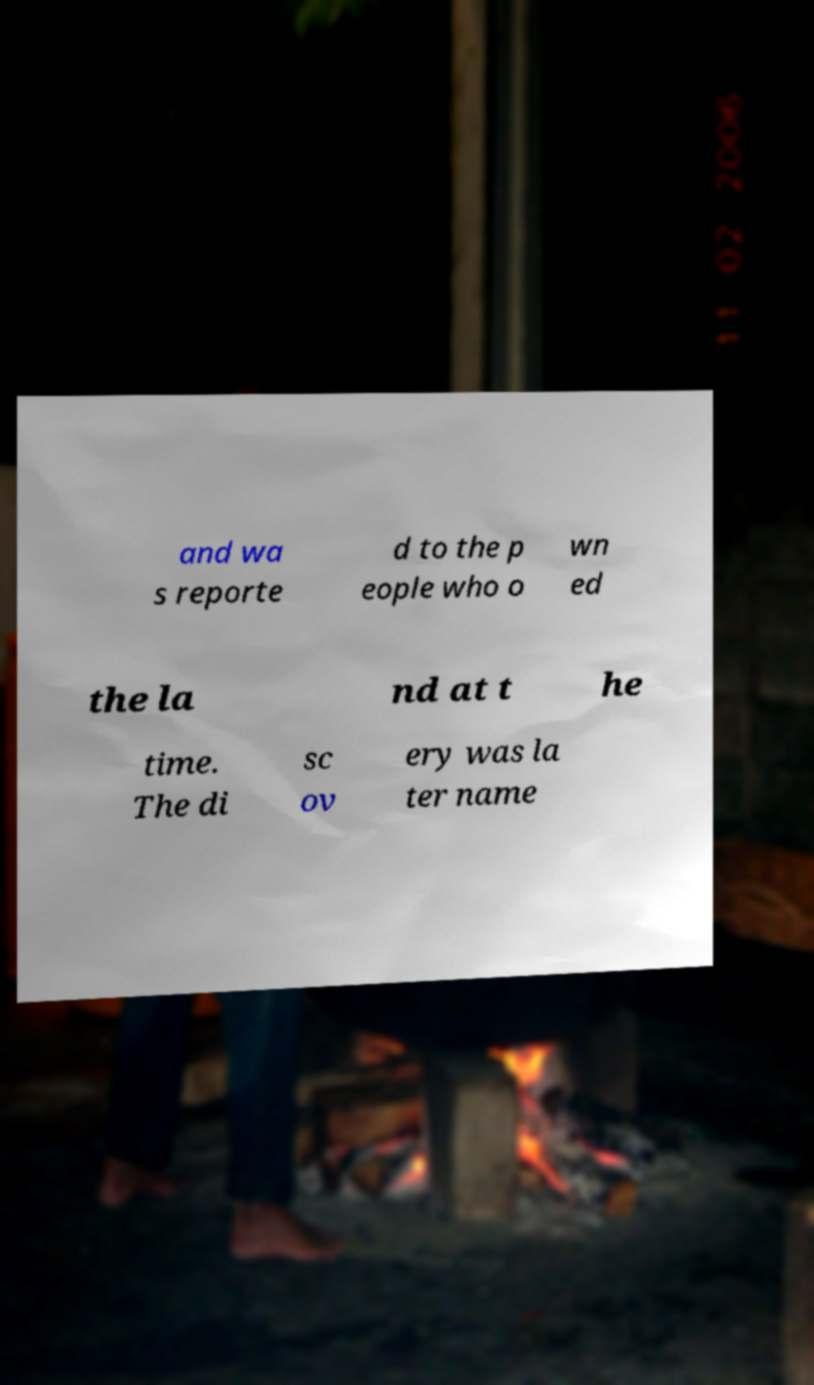Please identify and transcribe the text found in this image. and wa s reporte d to the p eople who o wn ed the la nd at t he time. The di sc ov ery was la ter name 